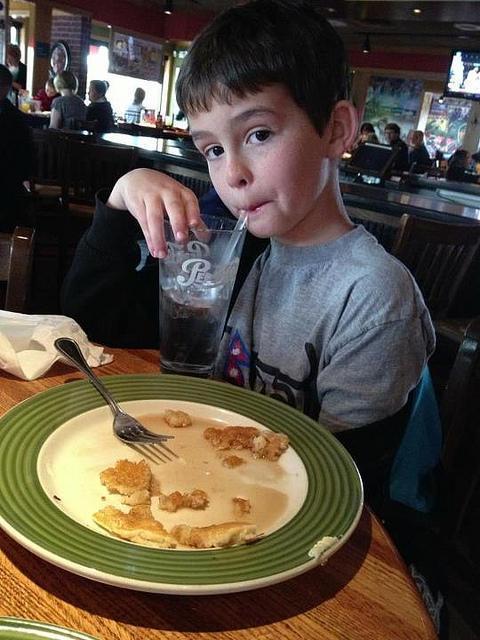How many people can you see?
Give a very brief answer. 2. How many cups are there?
Give a very brief answer. 1. How many chairs are there?
Give a very brief answer. 2. How many dining tables can be seen?
Give a very brief answer. 3. 